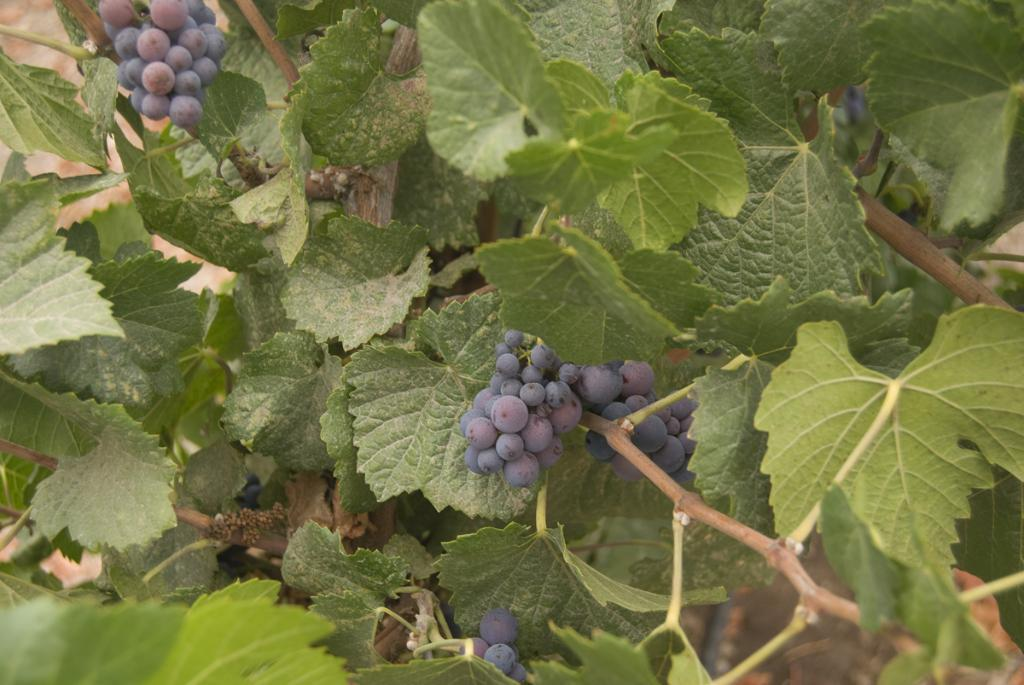What type of food is visible in the image? There is a bunch of fruits in the image. What kind of fruit do the fruits resemble? The fruits resemble grapes. Where are the fruits located in the image? The fruits are on a tree. What type of stage can be seen in the background of the image? There is no stage present in the image; it features a bunch of fruits on a tree. Is there a house visible in the image? There is no house visible in the image; it features a bunch of fruits on a tree. 